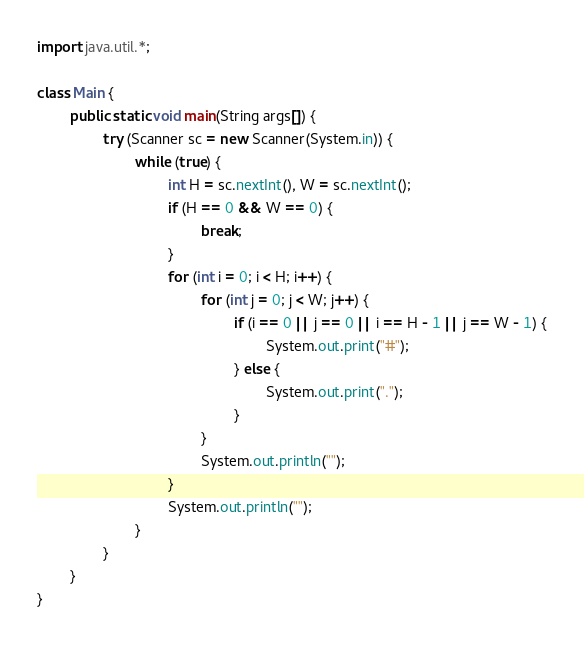<code> <loc_0><loc_0><loc_500><loc_500><_Java_>import java.util.*;

class Main {
        public static void main(String args[]) {
                try (Scanner sc = new Scanner(System.in)) {
                        while (true) {
                                int H = sc.nextInt(), W = sc.nextInt();
                                if (H == 0 && W == 0) {
                                        break;
                                }
                                for (int i = 0; i < H; i++) {
                                        for (int j = 0; j < W; j++) {
                                                if (i == 0 || j == 0 || i == H - 1 || j == W - 1) {
                                                        System.out.print("#");
                                                } else {
                                                        System.out.print(".");
                                                }
                                        }
                                        System.out.println("");
                                }
                                System.out.println("");
                        }
                }
        }
}</code> 